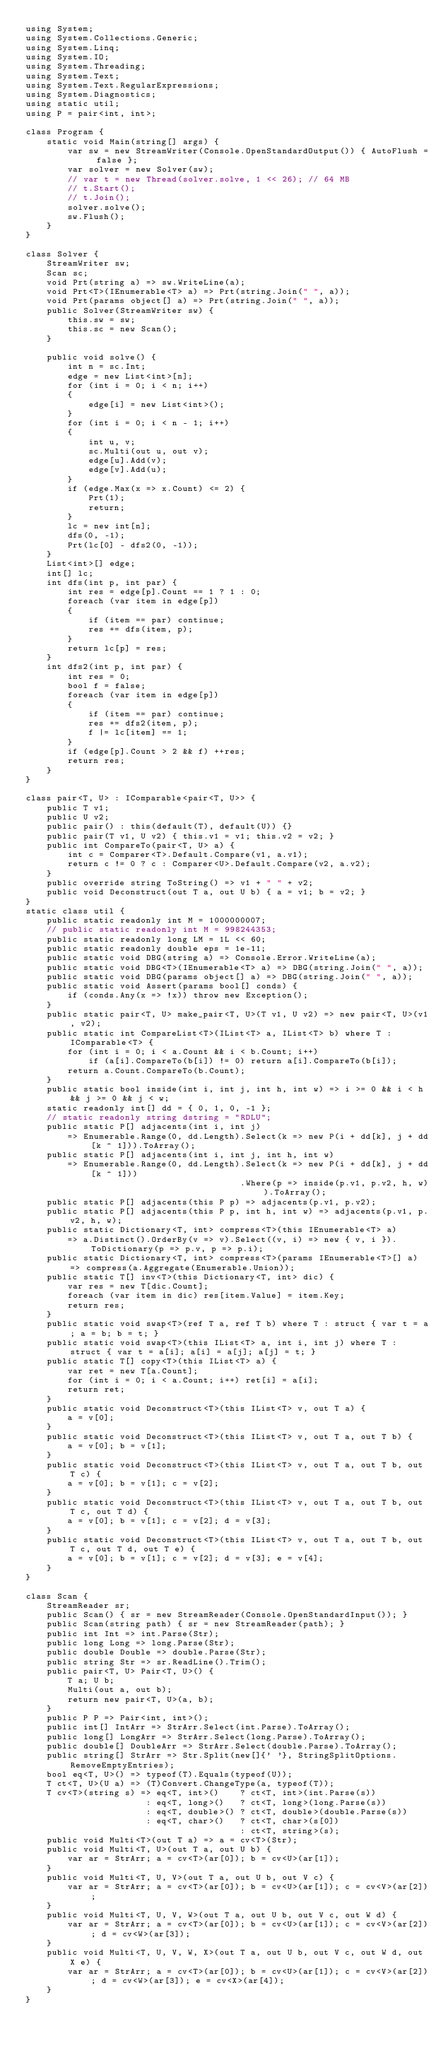Convert code to text. <code><loc_0><loc_0><loc_500><loc_500><_C#_>using System;
using System.Collections.Generic;
using System.Linq;
using System.IO;
using System.Threading;
using System.Text;
using System.Text.RegularExpressions;
using System.Diagnostics;
using static util;
using P = pair<int, int>;

class Program {
    static void Main(string[] args) {
        var sw = new StreamWriter(Console.OpenStandardOutput()) { AutoFlush = false };
        var solver = new Solver(sw);
        // var t = new Thread(solver.solve, 1 << 26); // 64 MB
        // t.Start();
        // t.Join();
        solver.solve();
        sw.Flush();
    }
}

class Solver {
    StreamWriter sw;
    Scan sc;
    void Prt(string a) => sw.WriteLine(a);
    void Prt<T>(IEnumerable<T> a) => Prt(string.Join(" ", a));
    void Prt(params object[] a) => Prt(string.Join(" ", a));
    public Solver(StreamWriter sw) {
        this.sw = sw;
        this.sc = new Scan();
    }

    public void solve() {
        int n = sc.Int;
        edge = new List<int>[n];
        for (int i = 0; i < n; i++)
        {
            edge[i] = new List<int>();
        }
        for (int i = 0; i < n - 1; i++)
        {
            int u, v;
            sc.Multi(out u, out v);
            edge[u].Add(v);
            edge[v].Add(u);
        }
        if (edge.Max(x => x.Count) <= 2) {
            Prt(1);
            return;
        }
        lc = new int[n];
        dfs(0, -1);
        Prt(lc[0] - dfs2(0, -1));
    }
    List<int>[] edge;
    int[] lc;
    int dfs(int p, int par) {
        int res = edge[p].Count == 1 ? 1 : 0;
        foreach (var item in edge[p])
        {
            if (item == par) continue;
            res += dfs(item, p);
        }
        return lc[p] = res;
    }
    int dfs2(int p, int par) {
        int res = 0;
        bool f = false;
        foreach (var item in edge[p])
        {
            if (item == par) continue;
            res += dfs2(item, p);
            f |= lc[item] == 1;
        }
        if (edge[p].Count > 2 && f) ++res;
        return res;
    }
}

class pair<T, U> : IComparable<pair<T, U>> {
    public T v1;
    public U v2;
    public pair() : this(default(T), default(U)) {}
    public pair(T v1, U v2) { this.v1 = v1; this.v2 = v2; }
    public int CompareTo(pair<T, U> a) {
        int c = Comparer<T>.Default.Compare(v1, a.v1);
        return c != 0 ? c : Comparer<U>.Default.Compare(v2, a.v2);
    }
    public override string ToString() => v1 + " " + v2;
    public void Deconstruct(out T a, out U b) { a = v1; b = v2; }
}
static class util {
    public static readonly int M = 1000000007;
    // public static readonly int M = 998244353;
    public static readonly long LM = 1L << 60;
    public static readonly double eps = 1e-11;
    public static void DBG(string a) => Console.Error.WriteLine(a);
    public static void DBG<T>(IEnumerable<T> a) => DBG(string.Join(" ", a));
    public static void DBG(params object[] a) => DBG(string.Join(" ", a));
    public static void Assert(params bool[] conds) {
        if (conds.Any(x => !x)) throw new Exception();
    }
    public static pair<T, U> make_pair<T, U>(T v1, U v2) => new pair<T, U>(v1, v2);
    public static int CompareList<T>(IList<T> a, IList<T> b) where T : IComparable<T> {
        for (int i = 0; i < a.Count && i < b.Count; i++)
            if (a[i].CompareTo(b[i]) != 0) return a[i].CompareTo(b[i]);
        return a.Count.CompareTo(b.Count);
    }
    public static bool inside(int i, int j, int h, int w) => i >= 0 && i < h && j >= 0 && j < w;
    static readonly int[] dd = { 0, 1, 0, -1 };
    // static readonly string dstring = "RDLU";
    public static P[] adjacents(int i, int j)
        => Enumerable.Range(0, dd.Length).Select(k => new P(i + dd[k], j + dd[k ^ 1])).ToArray();
    public static P[] adjacents(int i, int j, int h, int w)
        => Enumerable.Range(0, dd.Length).Select(k => new P(i + dd[k], j + dd[k ^ 1]))
                                         .Where(p => inside(p.v1, p.v2, h, w)).ToArray();
    public static P[] adjacents(this P p) => adjacents(p.v1, p.v2);
    public static P[] adjacents(this P p, int h, int w) => adjacents(p.v1, p.v2, h, w);
    public static Dictionary<T, int> compress<T>(this IEnumerable<T> a)
        => a.Distinct().OrderBy(v => v).Select((v, i) => new { v, i }).ToDictionary(p => p.v, p => p.i);
    public static Dictionary<T, int> compress<T>(params IEnumerable<T>[] a) => compress(a.Aggregate(Enumerable.Union));
    public static T[] inv<T>(this Dictionary<T, int> dic) {
        var res = new T[dic.Count];
        foreach (var item in dic) res[item.Value] = item.Key;
        return res;
    }
    public static void swap<T>(ref T a, ref T b) where T : struct { var t = a; a = b; b = t; }
    public static void swap<T>(this IList<T> a, int i, int j) where T : struct { var t = a[i]; a[i] = a[j]; a[j] = t; }
    public static T[] copy<T>(this IList<T> a) {
        var ret = new T[a.Count];
        for (int i = 0; i < a.Count; i++) ret[i] = a[i];
        return ret;
    }
    public static void Deconstruct<T>(this IList<T> v, out T a) {
        a = v[0];
    }
    public static void Deconstruct<T>(this IList<T> v, out T a, out T b) {
        a = v[0]; b = v[1];
    }
    public static void Deconstruct<T>(this IList<T> v, out T a, out T b, out T c) {
        a = v[0]; b = v[1]; c = v[2];
    }
    public static void Deconstruct<T>(this IList<T> v, out T a, out T b, out T c, out T d) {
        a = v[0]; b = v[1]; c = v[2]; d = v[3];
    }
    public static void Deconstruct<T>(this IList<T> v, out T a, out T b, out T c, out T d, out T e) {
        a = v[0]; b = v[1]; c = v[2]; d = v[3]; e = v[4];
    }
}

class Scan {
    StreamReader sr;
    public Scan() { sr = new StreamReader(Console.OpenStandardInput()); }
    public Scan(string path) { sr = new StreamReader(path); }
    public int Int => int.Parse(Str);
    public long Long => long.Parse(Str);
    public double Double => double.Parse(Str);
    public string Str => sr.ReadLine().Trim();
    public pair<T, U> Pair<T, U>() {
        T a; U b;
        Multi(out a, out b);
        return new pair<T, U>(a, b);
    }
    public P P => Pair<int, int>();
    public int[] IntArr => StrArr.Select(int.Parse).ToArray();
    public long[] LongArr => StrArr.Select(long.Parse).ToArray();
    public double[] DoubleArr => StrArr.Select(double.Parse).ToArray();
    public string[] StrArr => Str.Split(new[]{' '}, StringSplitOptions.RemoveEmptyEntries);
    bool eq<T, U>() => typeof(T).Equals(typeof(U));
    T ct<T, U>(U a) => (T)Convert.ChangeType(a, typeof(T));
    T cv<T>(string s) => eq<T, int>()    ? ct<T, int>(int.Parse(s))
                       : eq<T, long>()   ? ct<T, long>(long.Parse(s))
                       : eq<T, double>() ? ct<T, double>(double.Parse(s))
                       : eq<T, char>()   ? ct<T, char>(s[0])
                                         : ct<T, string>(s);
    public void Multi<T>(out T a) => a = cv<T>(Str);
    public void Multi<T, U>(out T a, out U b) {
        var ar = StrArr; a = cv<T>(ar[0]); b = cv<U>(ar[1]);
    }
    public void Multi<T, U, V>(out T a, out U b, out V c) {
        var ar = StrArr; a = cv<T>(ar[0]); b = cv<U>(ar[1]); c = cv<V>(ar[2]);
    }
    public void Multi<T, U, V, W>(out T a, out U b, out V c, out W d) {
        var ar = StrArr; a = cv<T>(ar[0]); b = cv<U>(ar[1]); c = cv<V>(ar[2]); d = cv<W>(ar[3]);
    }
    public void Multi<T, U, V, W, X>(out T a, out U b, out V c, out W d, out X e) {
        var ar = StrArr; a = cv<T>(ar[0]); b = cv<U>(ar[1]); c = cv<V>(ar[2]); d = cv<W>(ar[3]); e = cv<X>(ar[4]);
    }
}
</code> 